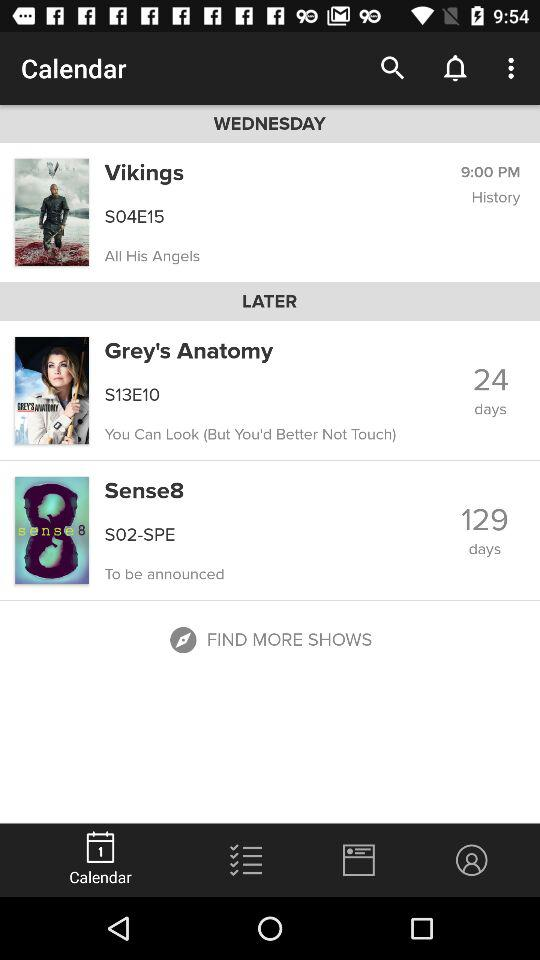How many episodes are in the current season of Grey's Anatomy?
Answer the question using a single word or phrase. 10 